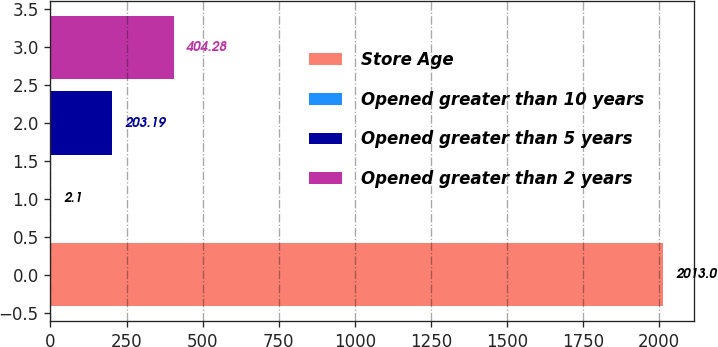Convert chart to OTSL. <chart><loc_0><loc_0><loc_500><loc_500><bar_chart><fcel>Store Age<fcel>Opened greater than 10 years<fcel>Opened greater than 5 years<fcel>Opened greater than 2 years<nl><fcel>2013<fcel>2.1<fcel>203.19<fcel>404.28<nl></chart> 